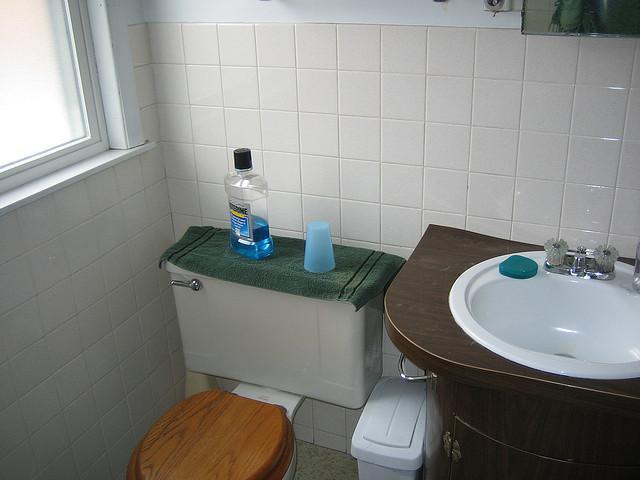How many people are wearing hats?
Give a very brief answer. 0. 